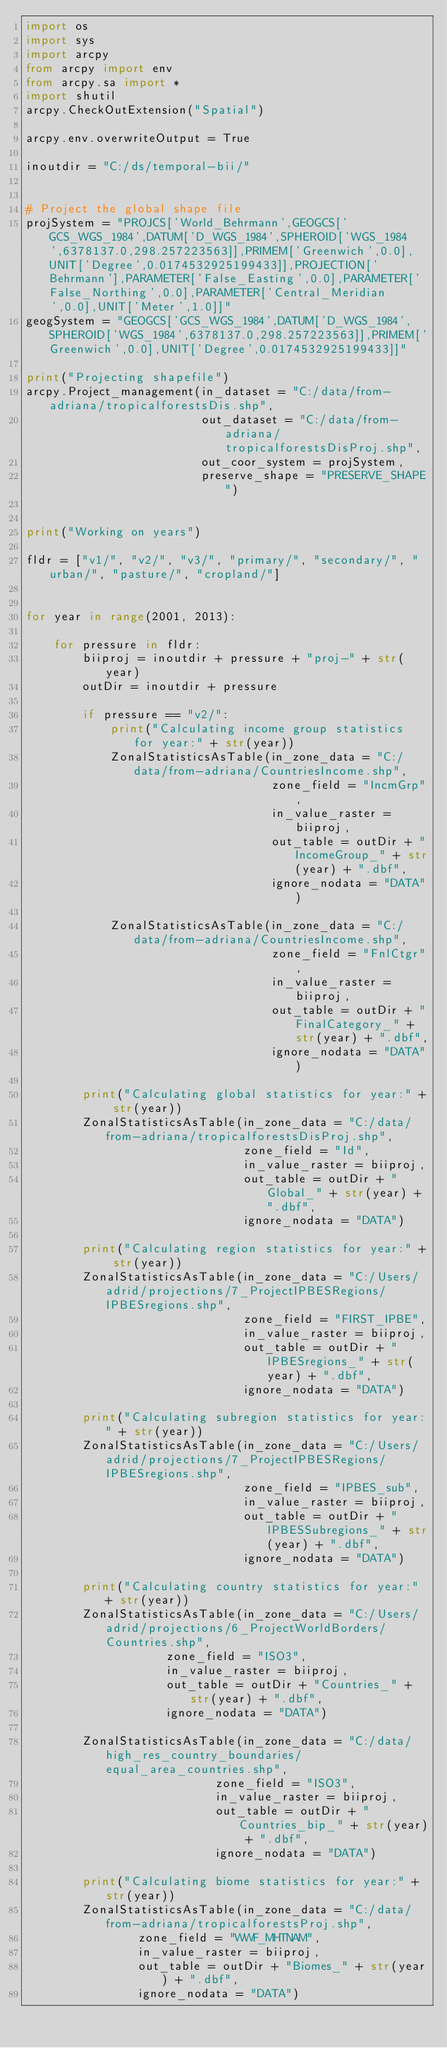Convert code to text. <code><loc_0><loc_0><loc_500><loc_500><_Python_>import os
import sys
import arcpy
from arcpy import env
from arcpy.sa import *
import shutil
arcpy.CheckOutExtension("Spatial")

arcpy.env.overwriteOutput = True

inoutdir = "C:/ds/temporal-bii/"


# Project the global shape file
projSystem = "PROJCS['World_Behrmann',GEOGCS['GCS_WGS_1984',DATUM['D_WGS_1984',SPHEROID['WGS_1984',6378137.0,298.257223563]],PRIMEM['Greenwich',0.0],UNIT['Degree',0.0174532925199433]],PROJECTION['Behrmann'],PARAMETER['False_Easting',0.0],PARAMETER['False_Northing',0.0],PARAMETER['Central_Meridian',0.0],UNIT['Meter',1.0]]"
geogSystem = "GEOGCS['GCS_WGS_1984',DATUM['D_WGS_1984',SPHEROID['WGS_1984',6378137.0,298.257223563]],PRIMEM['Greenwich',0.0],UNIT['Degree',0.0174532925199433]]"

print("Projecting shapefile")
arcpy.Project_management(in_dataset = "C:/data/from-adriana/tropicalforestsDis.shp",
                         out_dataset = "C:/data/from-adriana/tropicalforestsDisProj.shp",
                         out_coor_system = projSystem,
                         preserve_shape = "PRESERVE_SHAPE")


print("Working on years")

fldr = ["v1/", "v2/", "v3/", "primary/", "secondary/", "urban/", "pasture/", "cropland/"]


for year in range(2001, 2013):

    for pressure in fldr:
        biiproj = inoutdir + pressure + "proj-" + str(year)
        outDir = inoutdir + pressure

        if pressure == "v2/":
            print("Calculating income group statistics for year:" + str(year))
            ZonalStatisticsAsTable(in_zone_data = "C:/data/from-adriana/CountriesIncome.shp",
                                   zone_field = "IncmGrp",
                                   in_value_raster = biiproj,
                                   out_table = outDir + "IncomeGroup_" + str(year) + ".dbf",
                                   ignore_nodata = "DATA")

            ZonalStatisticsAsTable(in_zone_data = "C:/data/from-adriana/CountriesIncome.shp",
                                   zone_field = "FnlCtgr",
                                   in_value_raster = biiproj,
                                   out_table = outDir + "FinalCategory_" + str(year) + ".dbf",
                                   ignore_nodata = "DATA")

        print("Calculating global statistics for year:" + str(year))
        ZonalStatisticsAsTable(in_zone_data = "C:/data/from-adriana/tropicalforestsDisProj.shp",
                               zone_field = "Id",
                               in_value_raster = biiproj,
                               out_table = outDir + "Global_" + str(year) + ".dbf",
                               ignore_nodata = "DATA")
    
        print("Calculating region statistics for year:" + str(year))
        ZonalStatisticsAsTable(in_zone_data = "C:/Users/adrid/projections/7_ProjectIPBESRegions/IPBESregions.shp",
                               zone_field = "FIRST_IPBE",
                               in_value_raster = biiproj,
                               out_table = outDir + "IPBESregions_" + str(year) + ".dbf",
                               ignore_nodata = "DATA")

        print("Calculating subregion statistics for year:" + str(year))
        ZonalStatisticsAsTable(in_zone_data = "C:/Users/adrid/projections/7_ProjectIPBESRegions/IPBESregions.shp",
                               zone_field = "IPBES_sub",
                               in_value_raster = biiproj,
                               out_table = outDir + "IPBESSubregions_" + str(year) + ".dbf",
                               ignore_nodata = "DATA")

        print("Calculating country statistics for year:" + str(year))
        ZonalStatisticsAsTable(in_zone_data = "C:/Users/adrid/projections/6_ProjectWorldBorders/Countries.shp",
                    zone_field = "ISO3",
                    in_value_raster = biiproj,
                    out_table = outDir + "Countries_" + str(year) + ".dbf",
                    ignore_nodata = "DATA")

        ZonalStatisticsAsTable(in_zone_data = "C:/data/high_res_country_boundaries/equal_area_countries.shp",
                           zone_field = "ISO3",
                           in_value_raster = biiproj,
                           out_table = outDir + "Countries_bip_" + str(year) + ".dbf",
                           ignore_nodata = "DATA")

        print("Calculating biome statistics for year:" + str(year))
        ZonalStatisticsAsTable(in_zone_data = "C:/data/from-adriana/tropicalforestsProj.shp",
                zone_field = "WWF_MHTNAM",
                in_value_raster = biiproj,
                out_table = outDir + "Biomes_" + str(year) + ".dbf",
                ignore_nodata = "DATA")



</code> 